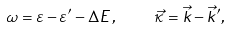<formula> <loc_0><loc_0><loc_500><loc_500>\omega = \varepsilon - \varepsilon ^ { \prime } - \Delta E \, , \quad \vec { \kappa } = \vec { k } - \vec { k } ^ { \prime } ,</formula> 